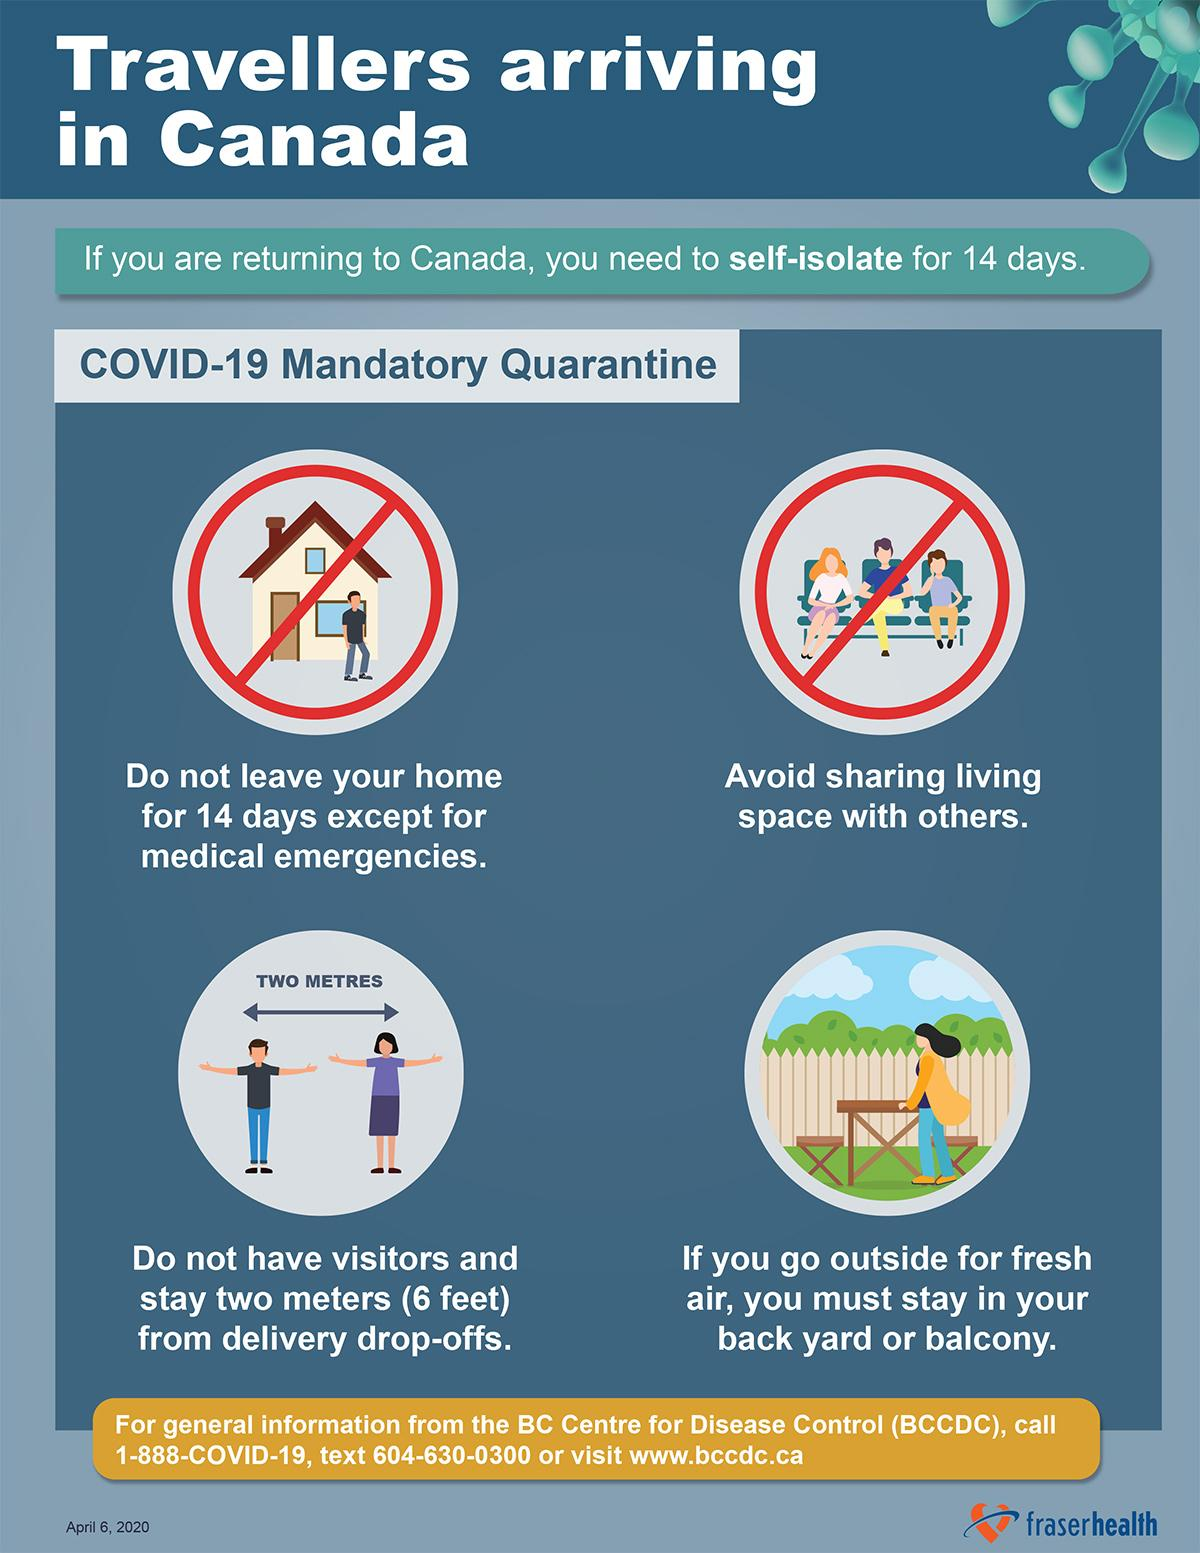List a handful of essential elements in this visual. The infographic image contains two dos. The infographic image contains two dos and three don'ts. 